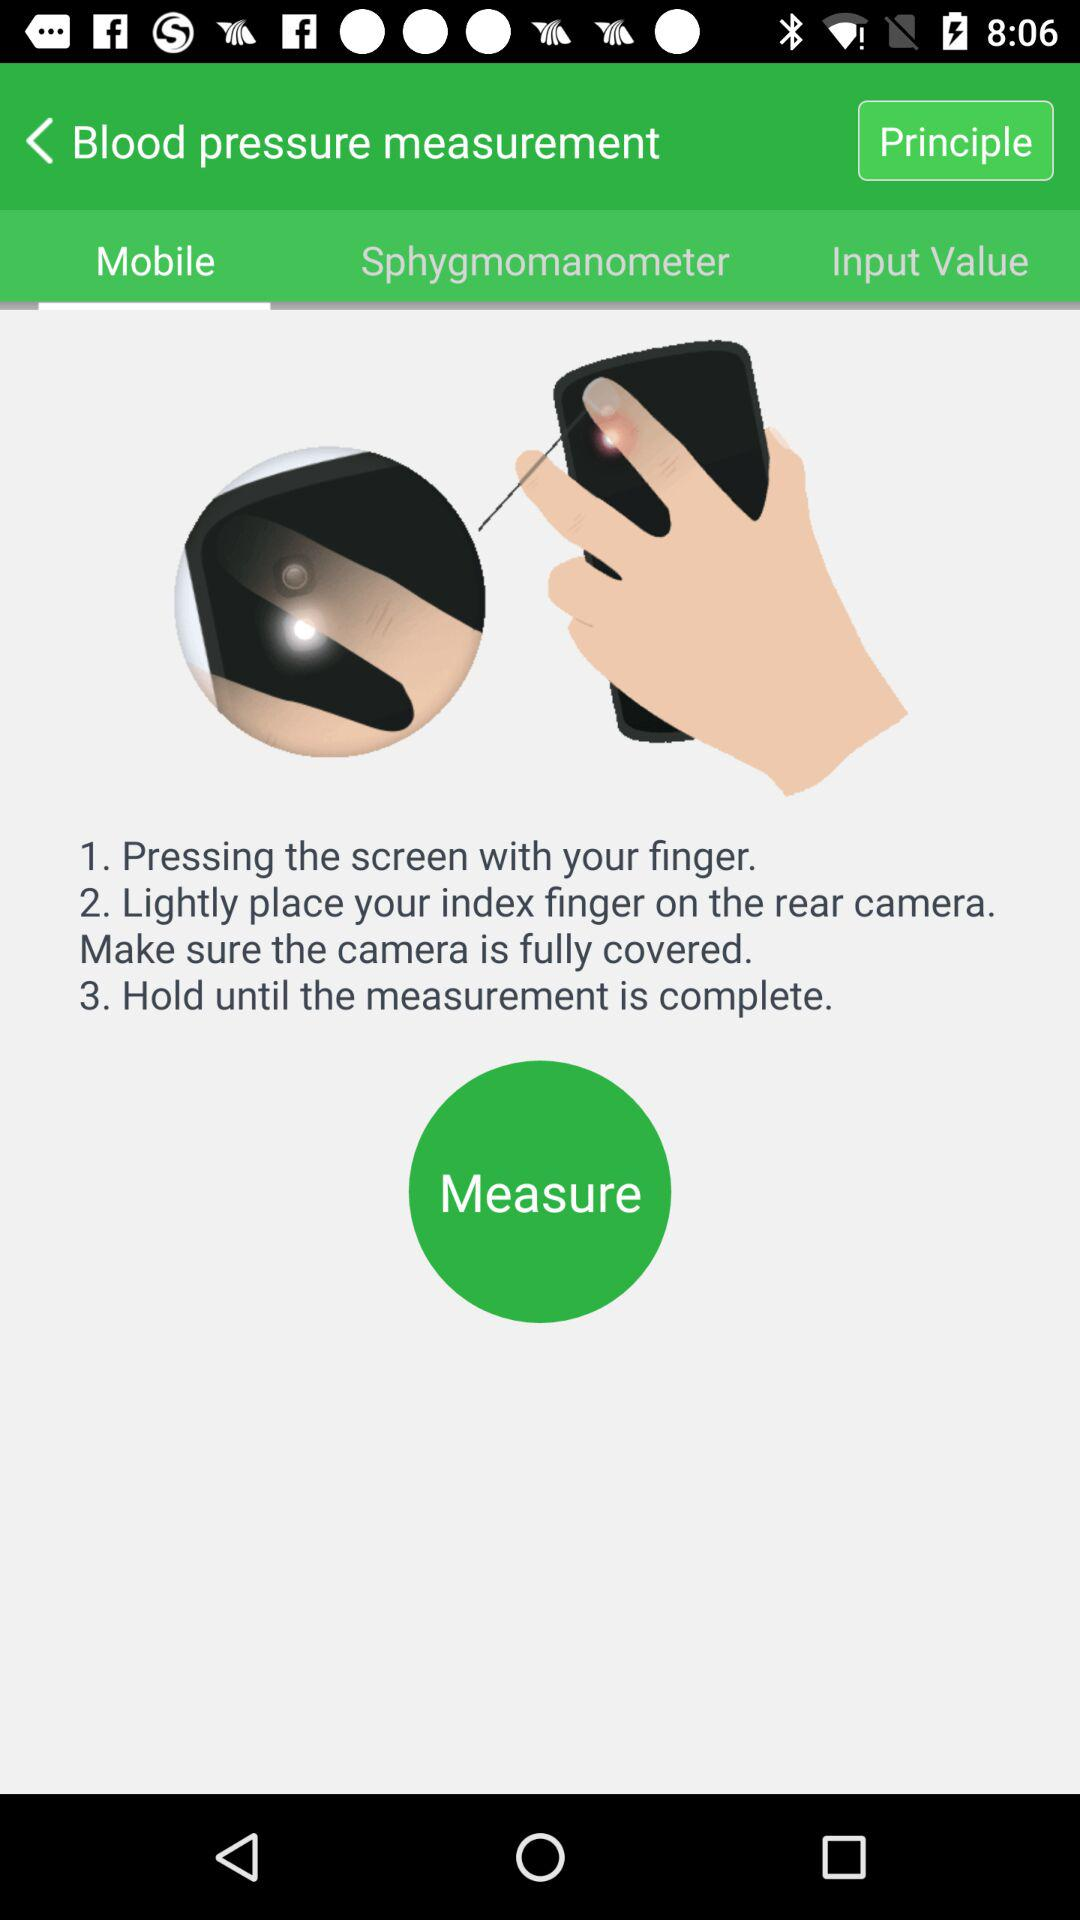How many steps are there in the instructions?
Answer the question using a single word or phrase. 3 